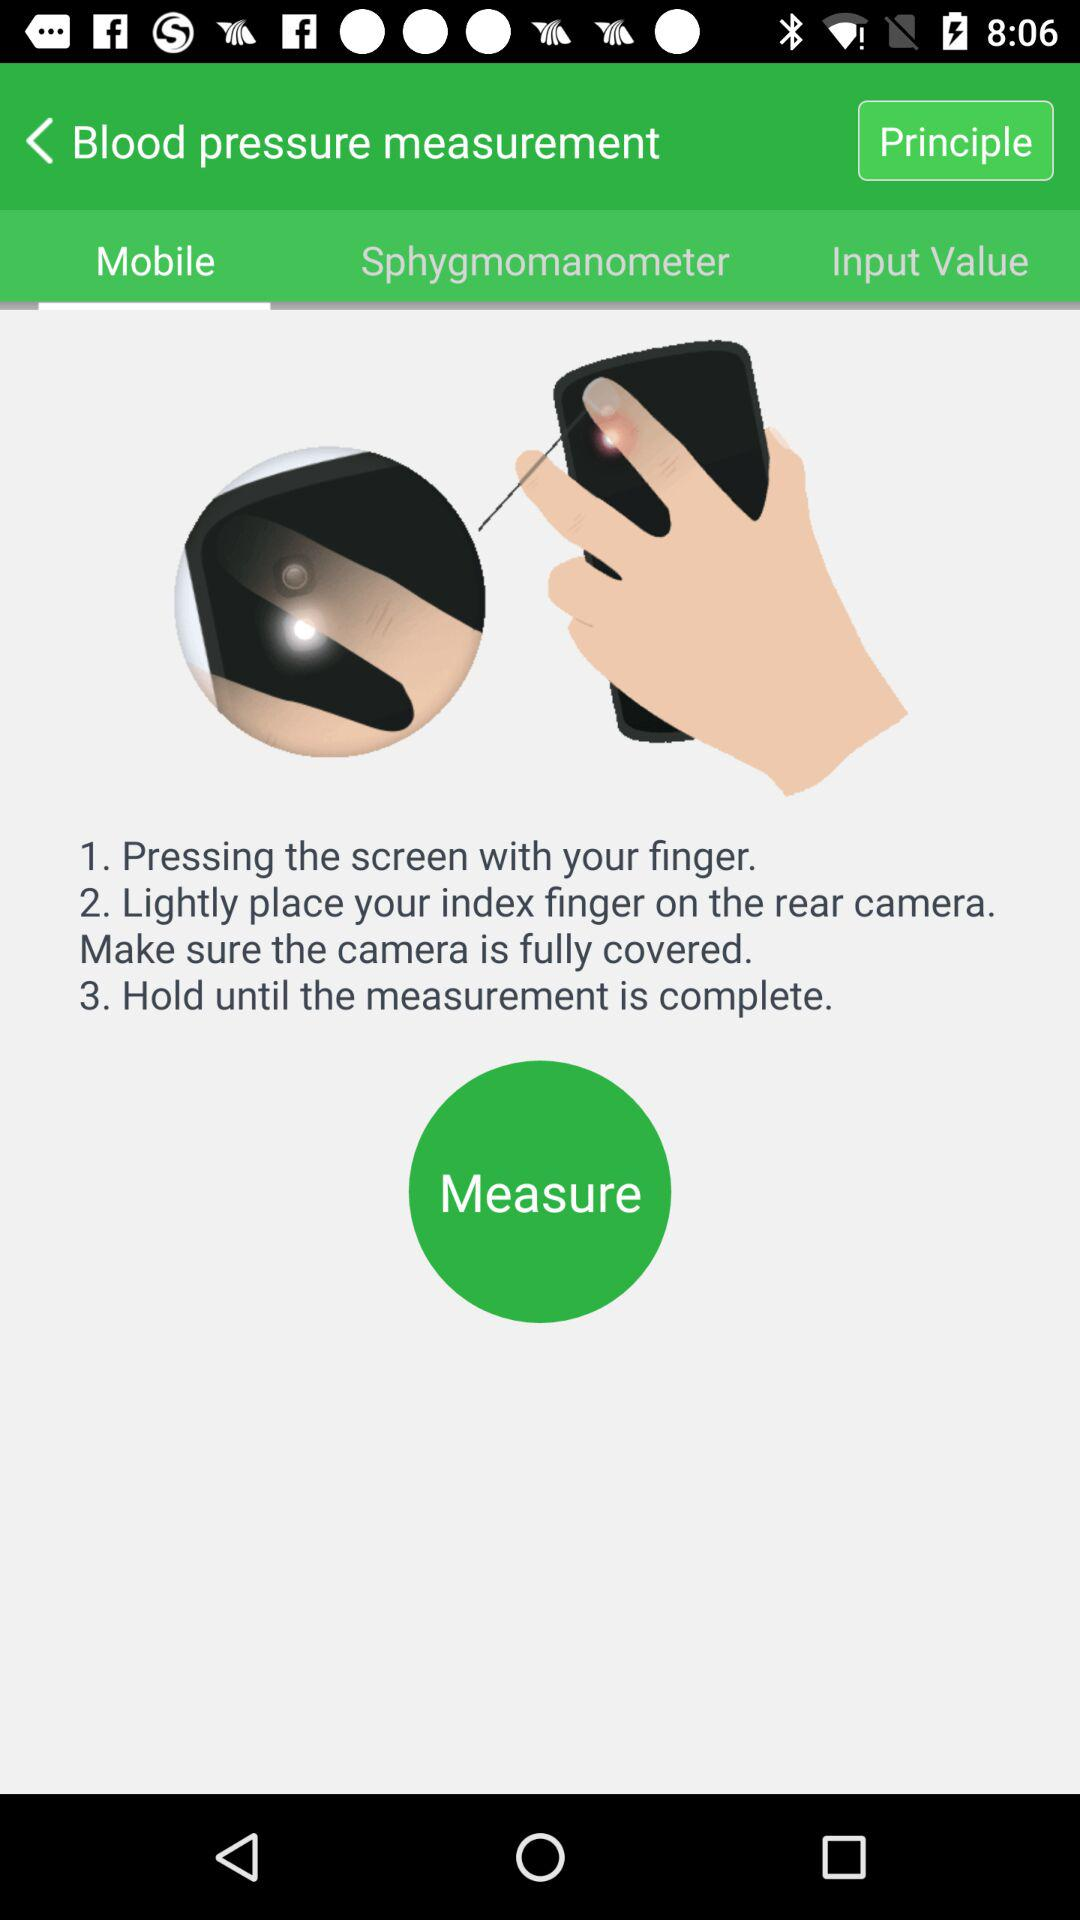How many steps are there in the instructions?
Answer the question using a single word or phrase. 3 